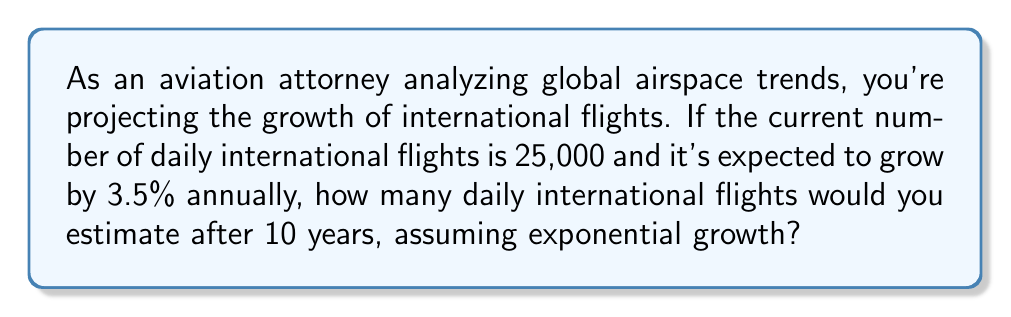Could you help me with this problem? Let's approach this step-by-step using an exponential growth model:

1) The exponential growth formula is:
   $A = P(1 + r)^t$
   Where:
   $A$ = final amount
   $P$ = initial amount (principal)
   $r$ = growth rate (as a decimal)
   $t$ = time period

2) Given:
   $P = 25,000$ (initial daily flights)
   $r = 0.035$ (3.5% annual growth rate)
   $t = 10$ years

3) Plugging these values into the formula:
   $A = 25,000(1 + 0.035)^{10}$

4) Simplify:
   $A = 25,000(1.035)^{10}$

5) Calculate:
   $A = 25,000 * 1.4105795$
   $A = 35,264.49$

6) Round to the nearest whole number:
   $A ≈ 35,264$ daily international flights
Answer: 35,264 daily international flights 